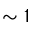Convert formula to latex. <formula><loc_0><loc_0><loc_500><loc_500>\sim 1</formula> 